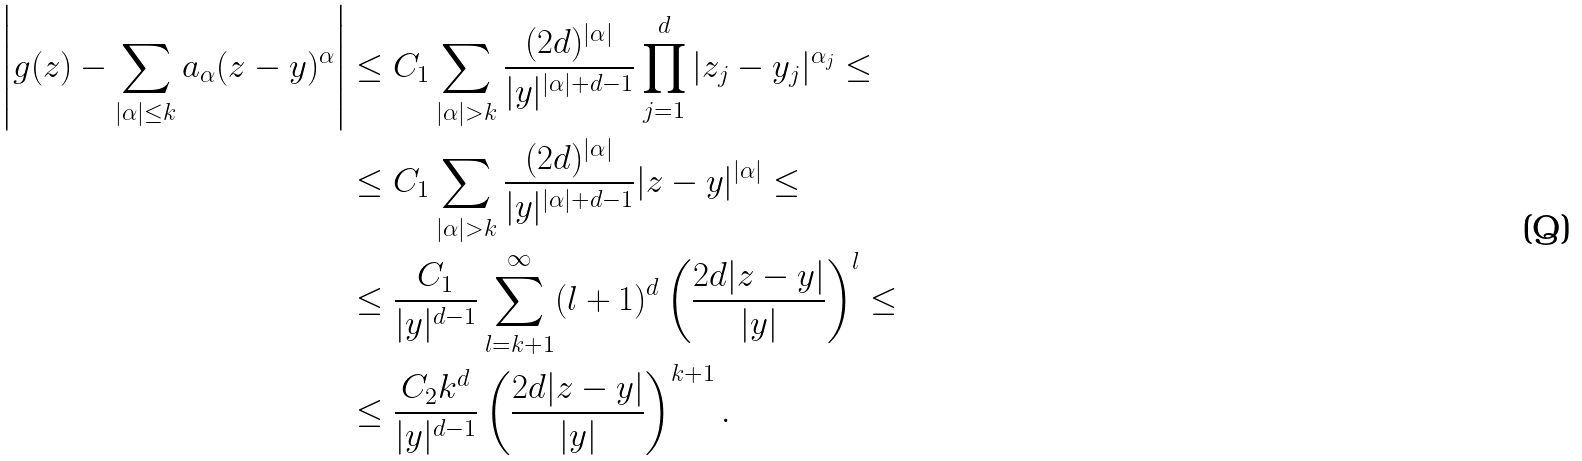Convert formula to latex. <formula><loc_0><loc_0><loc_500><loc_500>\left | g ( z ) - \sum _ { | \alpha | \leq k } a _ { \alpha } ( z - y ) ^ { \alpha } \right | & \leq C _ { 1 } \sum _ { | \alpha | > k } \frac { ( 2 d ) ^ { | \alpha | } } { | y | ^ { | \alpha | + d - 1 } } \prod _ { j = 1 } ^ { d } | z _ { j } - y _ { j } | ^ { \alpha _ { j } } \leq \\ & \leq C _ { 1 } \sum _ { | \alpha | > k } \frac { ( 2 d ) ^ { | \alpha | } } { | y | ^ { | \alpha | + d - 1 } } | z - y | ^ { | \alpha | } \leq \\ & \leq \frac { C _ { 1 } } { | y | ^ { d - 1 } } \sum _ { l = k + 1 } ^ { \infty } ( l + 1 ) ^ { d } \left ( \frac { 2 d | z - y | } { | y | } \right ) ^ { l } \leq \\ & \leq \frac { C _ { 2 } k ^ { d } } { | y | ^ { d - 1 } } \left ( \frac { 2 d | z - y | } { | y | } \right ) ^ { k + 1 } .</formula> 